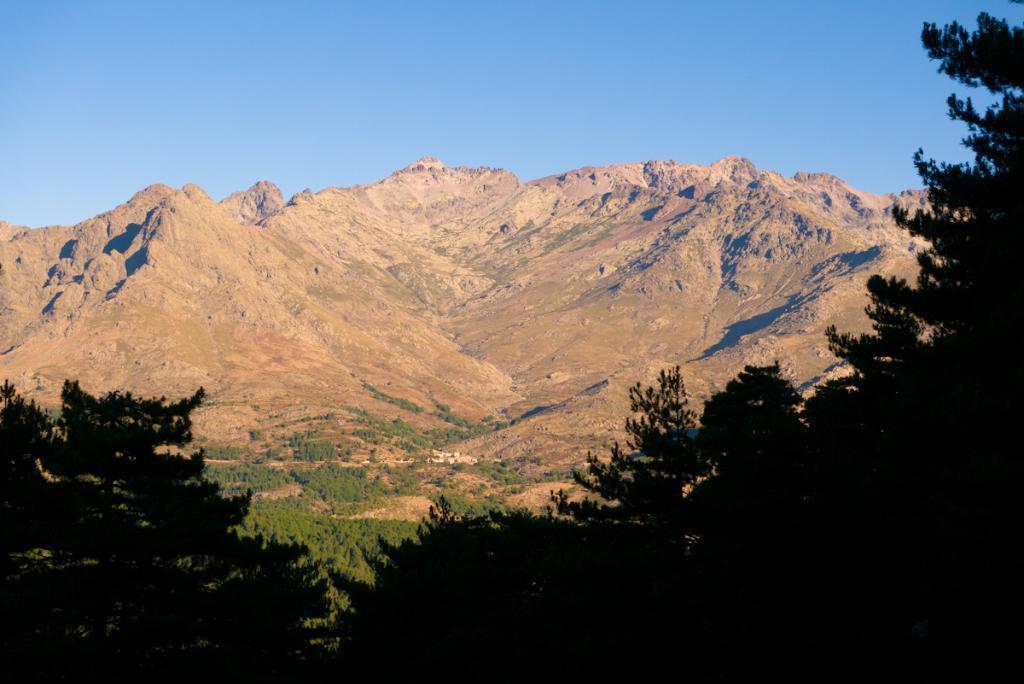How would you summarize this image in a sentence or two? In this image at the bottom and on the right side we can see trees. In the background there are trees, mountains and sky. 